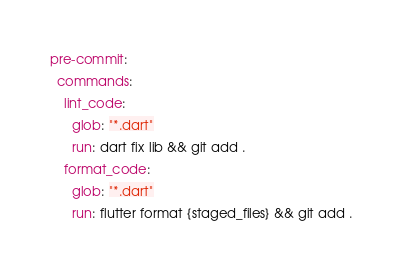Convert code to text. <code><loc_0><loc_0><loc_500><loc_500><_YAML_>pre-commit:
  commands:
    lint_code:
      glob: "*.dart"
      run: dart fix lib && git add .
    format_code:
      glob: "*.dart"
      run: flutter format {staged_files} && git add .
</code> 